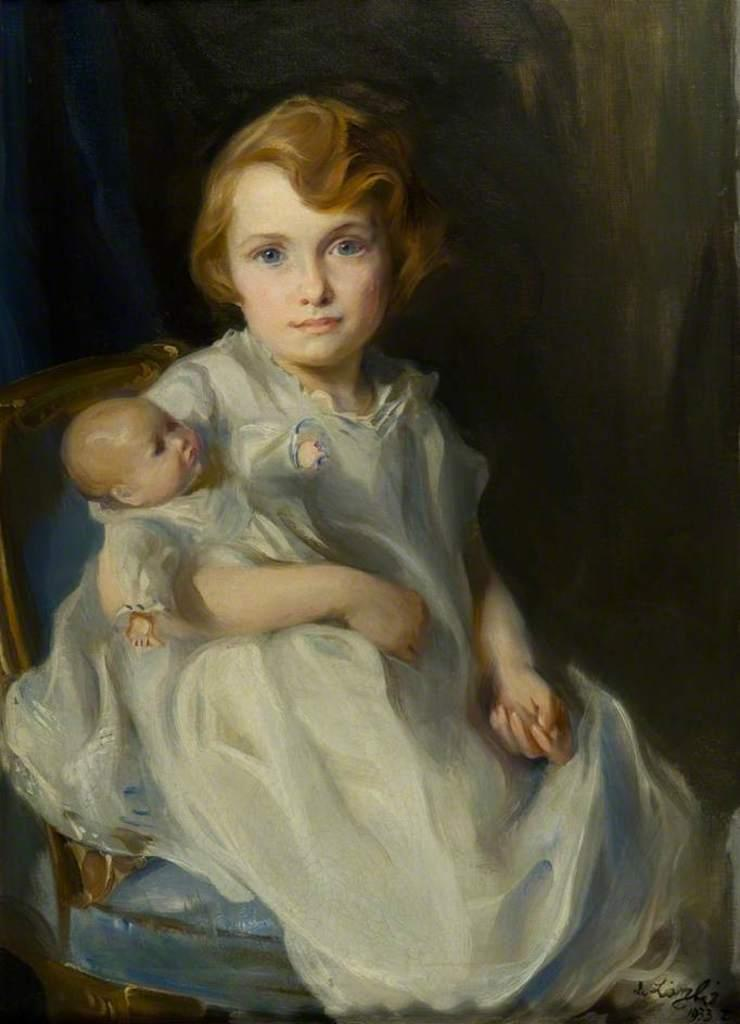What is the main subject of the painting in the image? The painting depicts a woman. What is the woman wearing in the painting? The woman is wearing a white dress in the painting. What is the woman doing in the painting? The woman is sitting on a chair and carrying a child in the painting. What color is the minute hand on the clock in the painting? There is no clock present in the painting, so it is not possible to determine the color of the minute hand. 